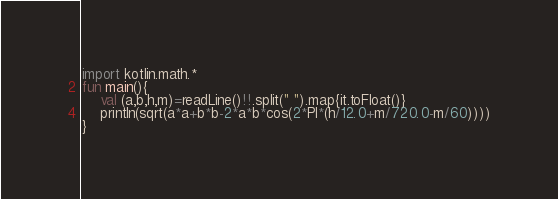Convert code to text. <code><loc_0><loc_0><loc_500><loc_500><_Kotlin_>import kotlin.math.*
fun main(){
	val (a,b,h,m)=readLine()!!.split(" ").map{it.toFloat()}
	println(sqrt(a*a+b*b-2*a*b*cos(2*PI*(h/12.0+m/720.0-m/60))))
}</code> 